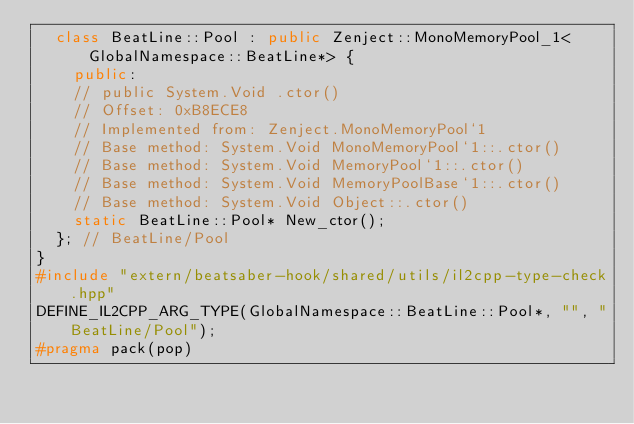Convert code to text. <code><loc_0><loc_0><loc_500><loc_500><_C++_>  class BeatLine::Pool : public Zenject::MonoMemoryPool_1<GlobalNamespace::BeatLine*> {
    public:
    // public System.Void .ctor()
    // Offset: 0xB8ECE8
    // Implemented from: Zenject.MonoMemoryPool`1
    // Base method: System.Void MonoMemoryPool`1::.ctor()
    // Base method: System.Void MemoryPool`1::.ctor()
    // Base method: System.Void MemoryPoolBase`1::.ctor()
    // Base method: System.Void Object::.ctor()
    static BeatLine::Pool* New_ctor();
  }; // BeatLine/Pool
}
#include "extern/beatsaber-hook/shared/utils/il2cpp-type-check.hpp"
DEFINE_IL2CPP_ARG_TYPE(GlobalNamespace::BeatLine::Pool*, "", "BeatLine/Pool");
#pragma pack(pop)
</code> 